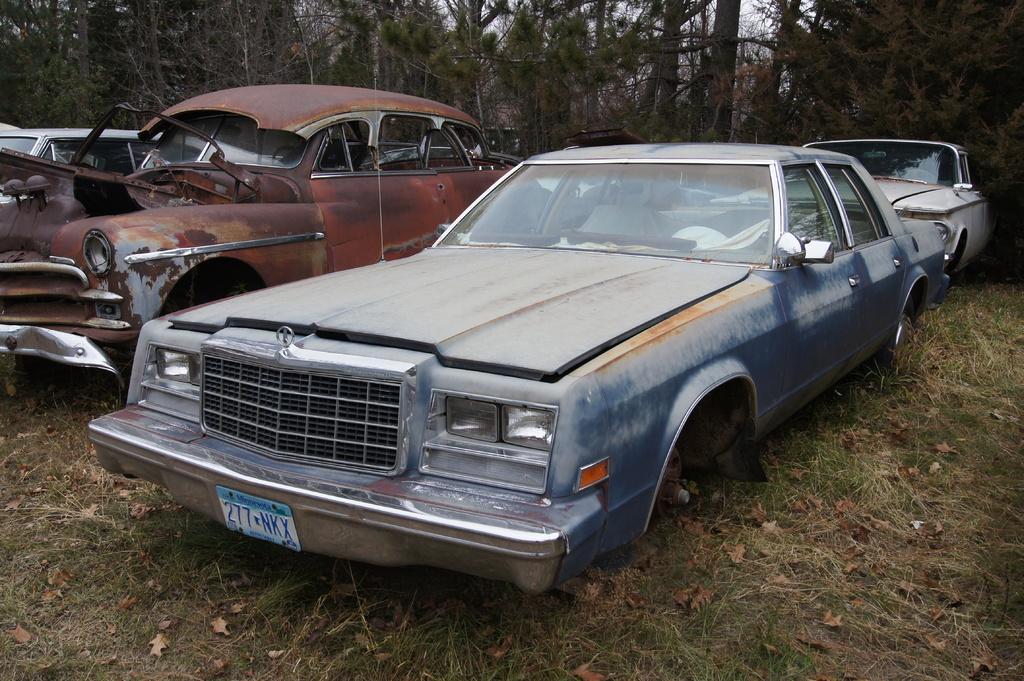Describe this image in one or two sentences. In this image we can few cars, grass, leaves on the ground, there are trees, also we can see the sky. 